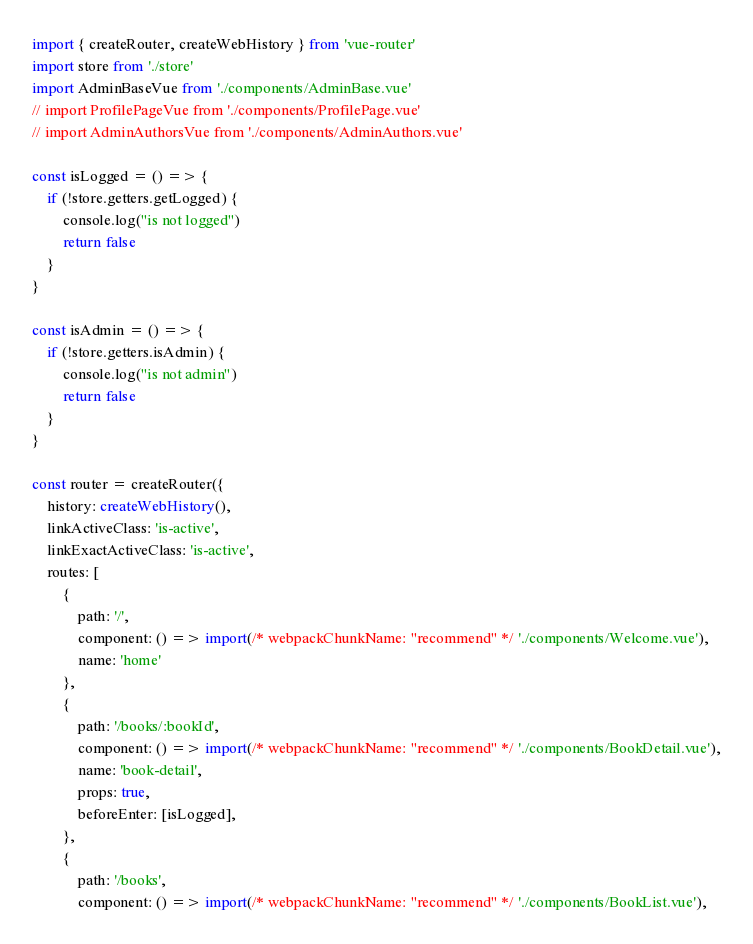Convert code to text. <code><loc_0><loc_0><loc_500><loc_500><_TypeScript_>import { createRouter, createWebHistory } from 'vue-router'
import store from './store'
import AdminBaseVue from './components/AdminBase.vue'
// import ProfilePageVue from './components/ProfilePage.vue'
// import AdminAuthorsVue from './components/AdminAuthors.vue'

const isLogged = () => {
    if (!store.getters.getLogged) {
        console.log("is not logged")
        return false
    }
}

const isAdmin = () => {
    if (!store.getters.isAdmin) {
        console.log("is not admin")
        return false
    }
}

const router = createRouter({
    history: createWebHistory(),
    linkActiveClass: 'is-active',
    linkExactActiveClass: 'is-active',
    routes: [
        {
            path: '/',
            component: () => import(/* webpackChunkName: "recommend" */ './components/Welcome.vue'),
            name: 'home'
        },
        {
            path: '/books/:bookId',
            component: () => import(/* webpackChunkName: "recommend" */ './components/BookDetail.vue'),
            name: 'book-detail',
            props: true,
            beforeEnter: [isLogged],
        },
        {
            path: '/books',
            component: () => import(/* webpackChunkName: "recommend" */ './components/BookList.vue'),</code> 